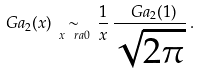<formula> <loc_0><loc_0><loc_500><loc_500>\ G a _ { 2 } ( x ) \, \underset { x \ r a 0 } \sim \, \frac { 1 } { x } \, \frac { \ G a _ { 2 } ( 1 ) } { \sqrt { 2 \pi } } \, .</formula> 